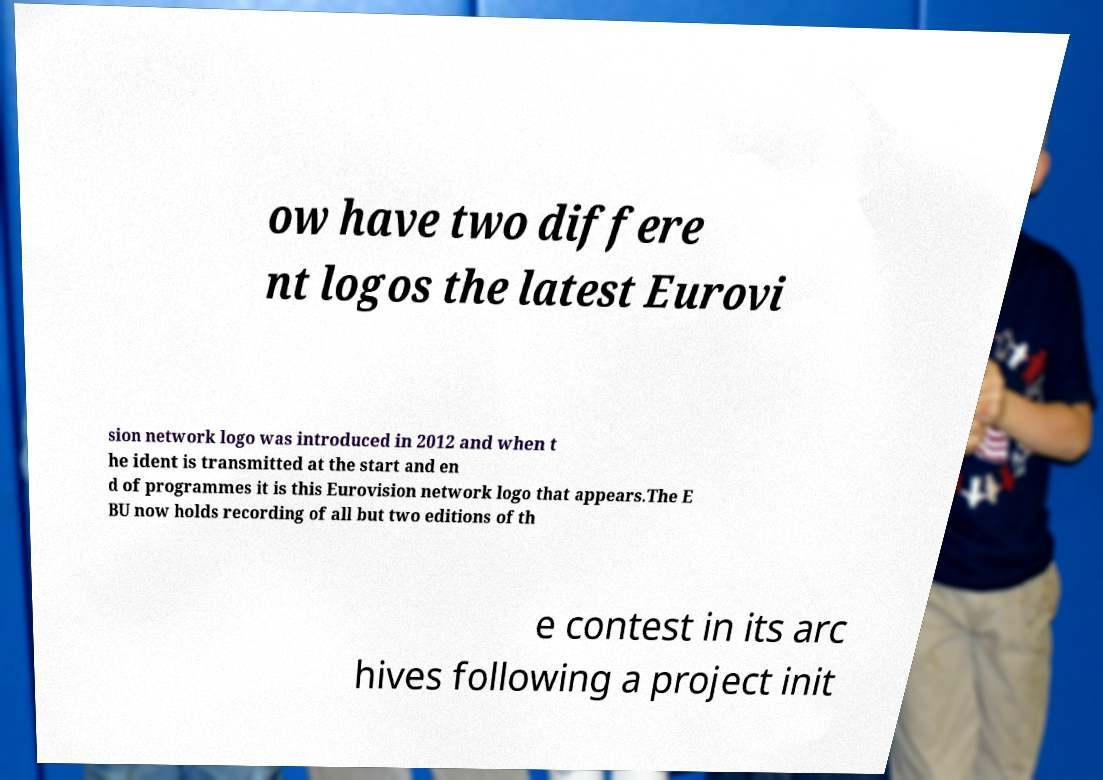For documentation purposes, I need the text within this image transcribed. Could you provide that? ow have two differe nt logos the latest Eurovi sion network logo was introduced in 2012 and when t he ident is transmitted at the start and en d of programmes it is this Eurovision network logo that appears.The E BU now holds recording of all but two editions of th e contest in its arc hives following a project init 